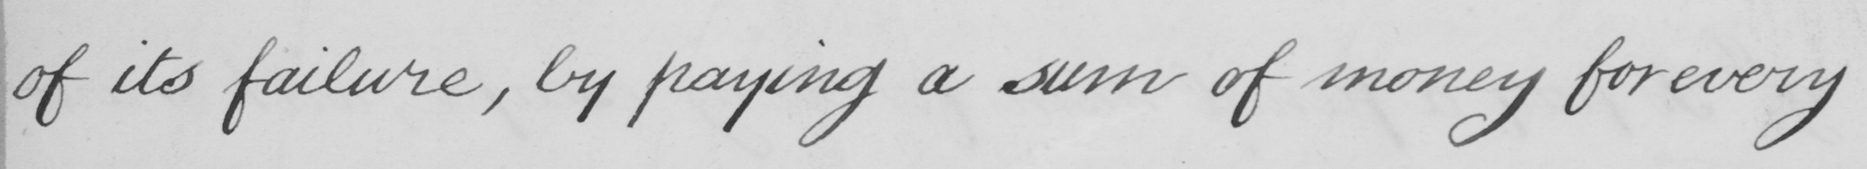Can you tell me what this handwritten text says? of its failure , by paying a sum of money for every 